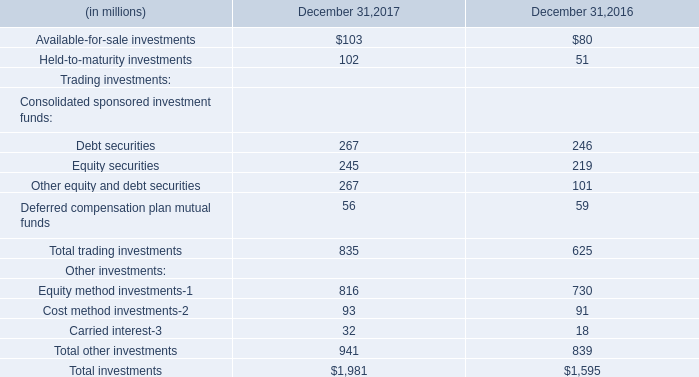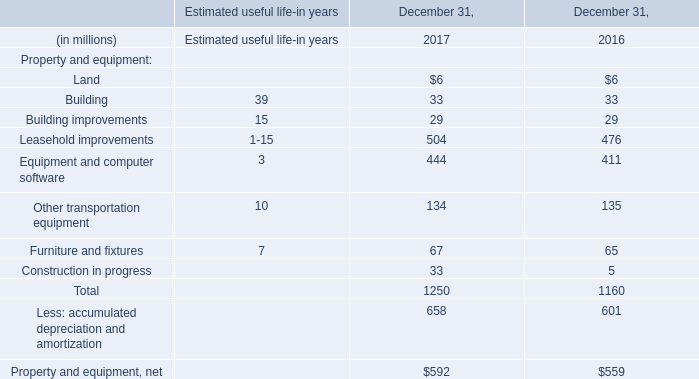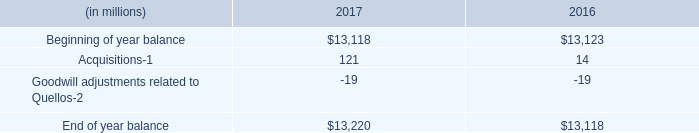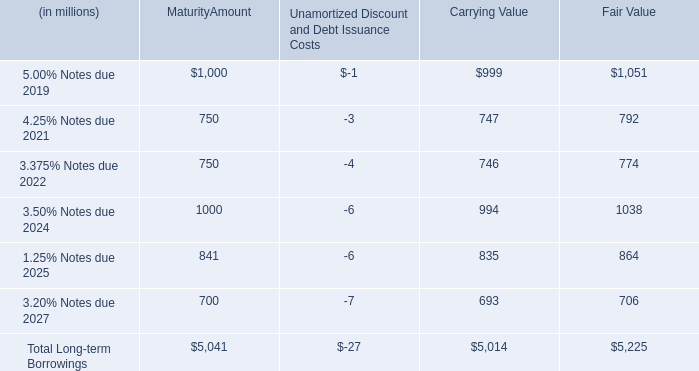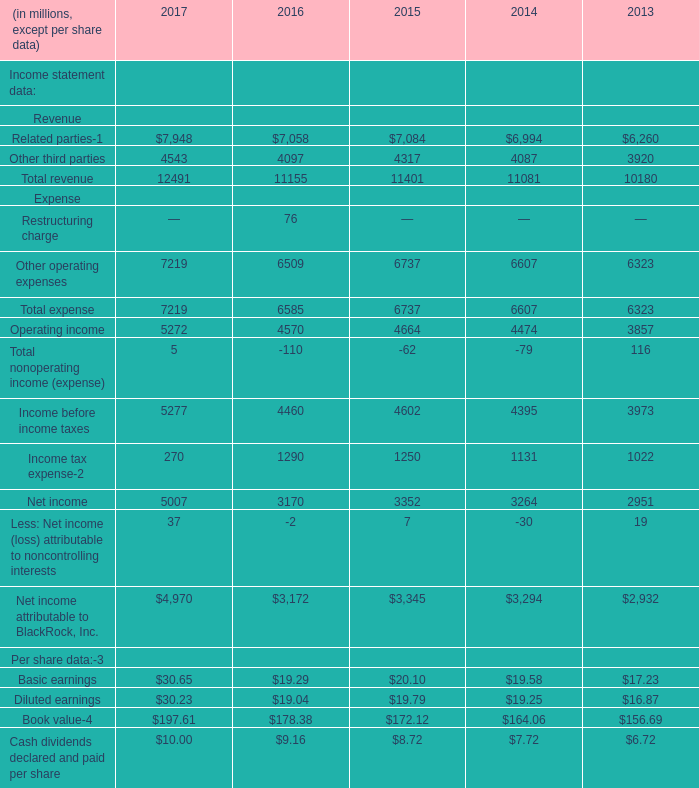What is the growing rate of Total expense in the years with the least Other operating expenses? 
Computations: ((6607 - 6323) / 6323)
Answer: 0.04492. 